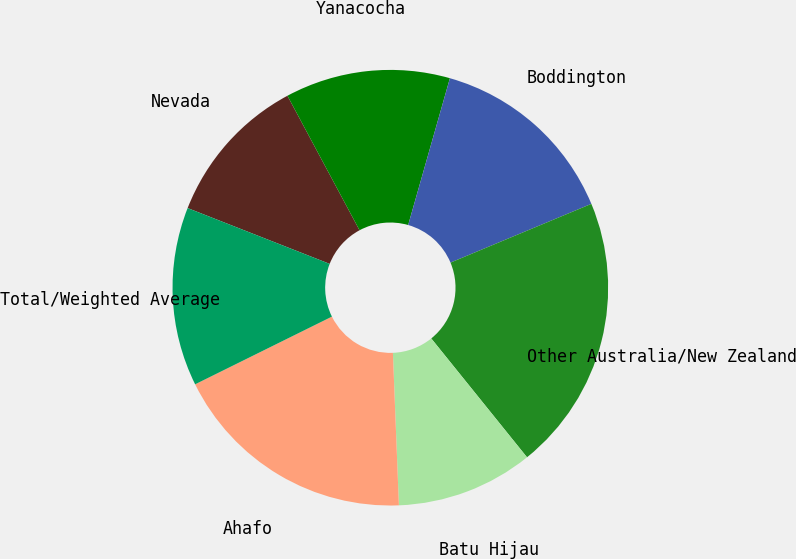<chart> <loc_0><loc_0><loc_500><loc_500><pie_chart><fcel>Nevada<fcel>Yanacocha<fcel>Boddington<fcel>Other Australia/New Zealand<fcel>Batu Hijau<fcel>Ahafo<fcel>Total/Weighted Average<nl><fcel>11.21%<fcel>12.24%<fcel>14.3%<fcel>20.49%<fcel>10.17%<fcel>18.31%<fcel>13.27%<nl></chart> 